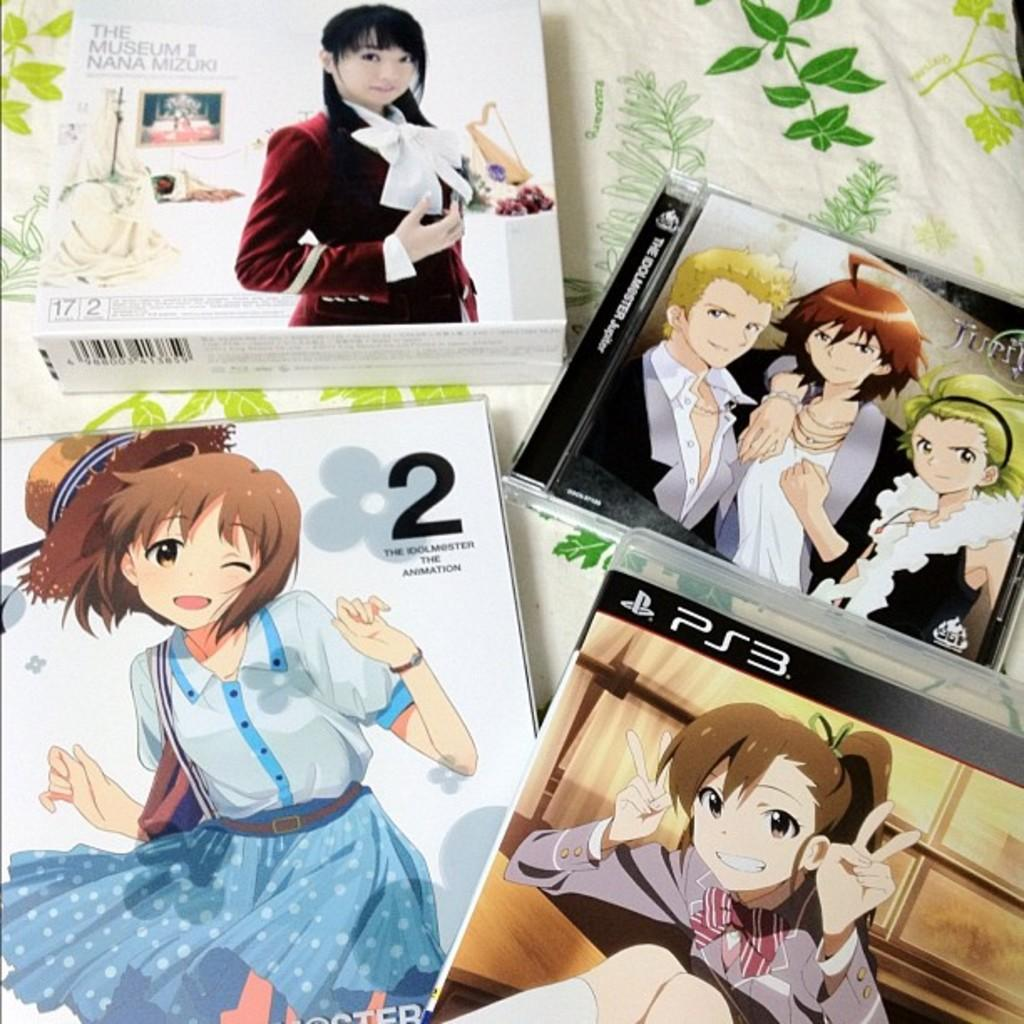What objects are present in the image? There are boxes in the image. What is depicted on the boxes? There are cartoons printed on the boxes. What type of mountain can be seen in the background of the image? There is no mountain present in the image; it only features boxes with cartoons printed on them. What substance is being stored in the boxes? The contents of the boxes are not specified in the image, so it cannot be determined what substance might be stored inside. 